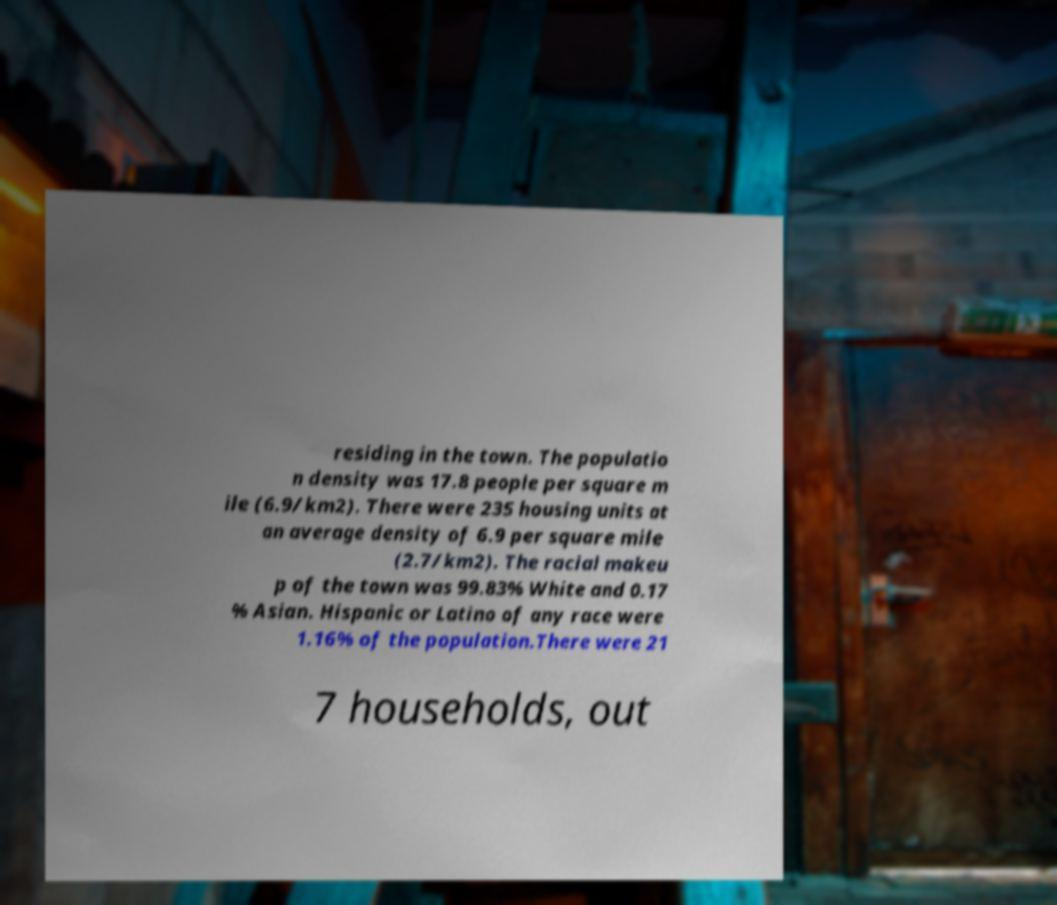What messages or text are displayed in this image? I need them in a readable, typed format. residing in the town. The populatio n density was 17.8 people per square m ile (6.9/km2). There were 235 housing units at an average density of 6.9 per square mile (2.7/km2). The racial makeu p of the town was 99.83% White and 0.17 % Asian. Hispanic or Latino of any race were 1.16% of the population.There were 21 7 households, out 